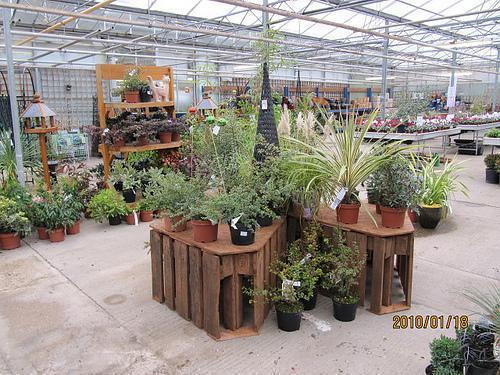What can be found here?
Choose the correct response and explain in the format: 'Answer: answer
Rationale: rationale.'
Options: Cats, dogs, bats, pots. Answer: pots.
Rationale: The other options don't apply to a greenhouse or garden store setting. 